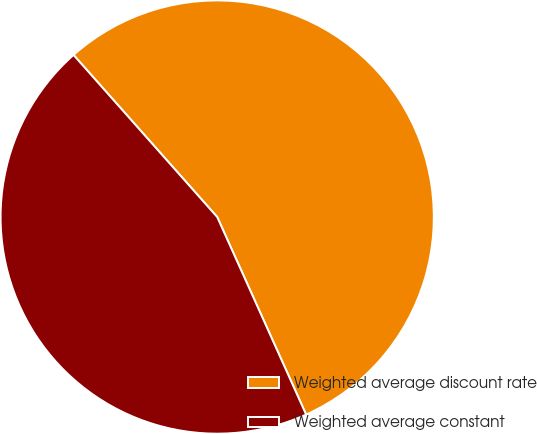Convert chart. <chart><loc_0><loc_0><loc_500><loc_500><pie_chart><fcel>Weighted average discount rate<fcel>Weighted average constant<nl><fcel>54.81%<fcel>45.19%<nl></chart> 